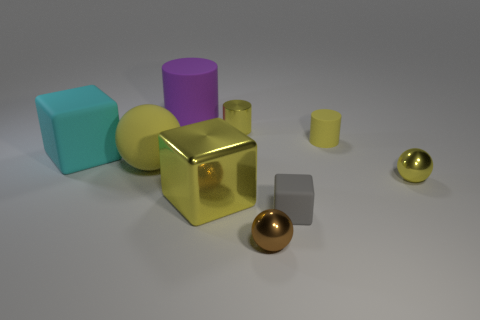What is the material of the yellow cylinder that is behind the rubber cylinder in front of the big purple thing? metal 